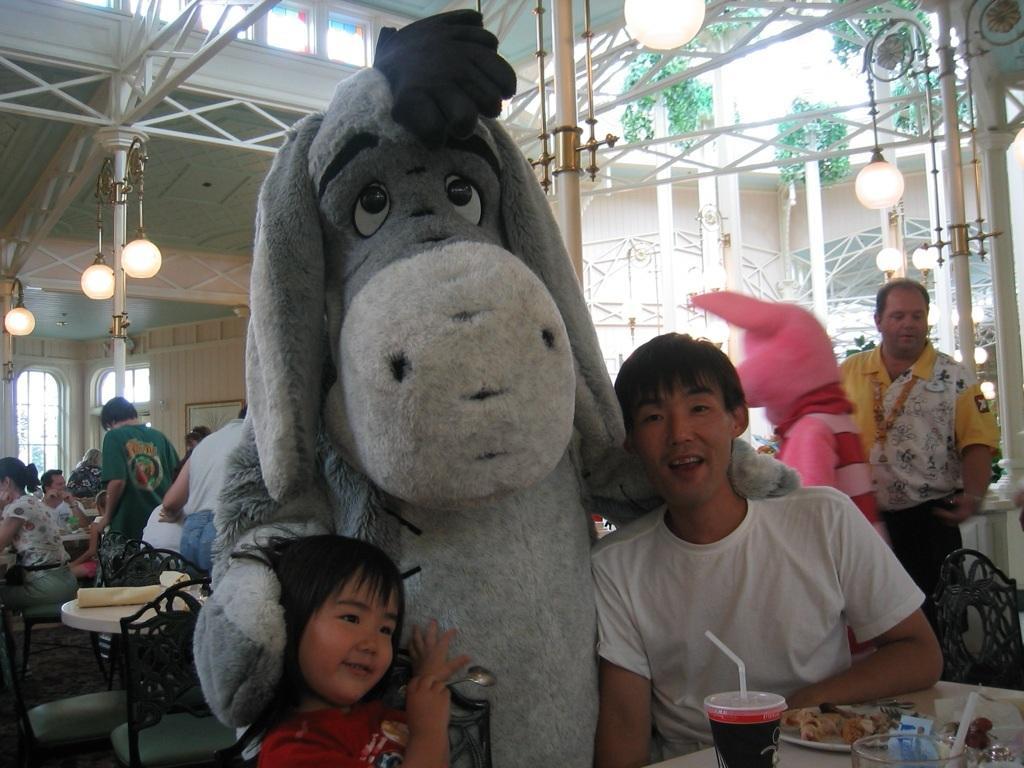Please provide a concise description of this image. In this picture there are people and we can see mascots and chairs. We can see plate, food and objects on tables. We can see lights and poles. In the background of the image we can see windows, railing, frame on the wall and plants. 